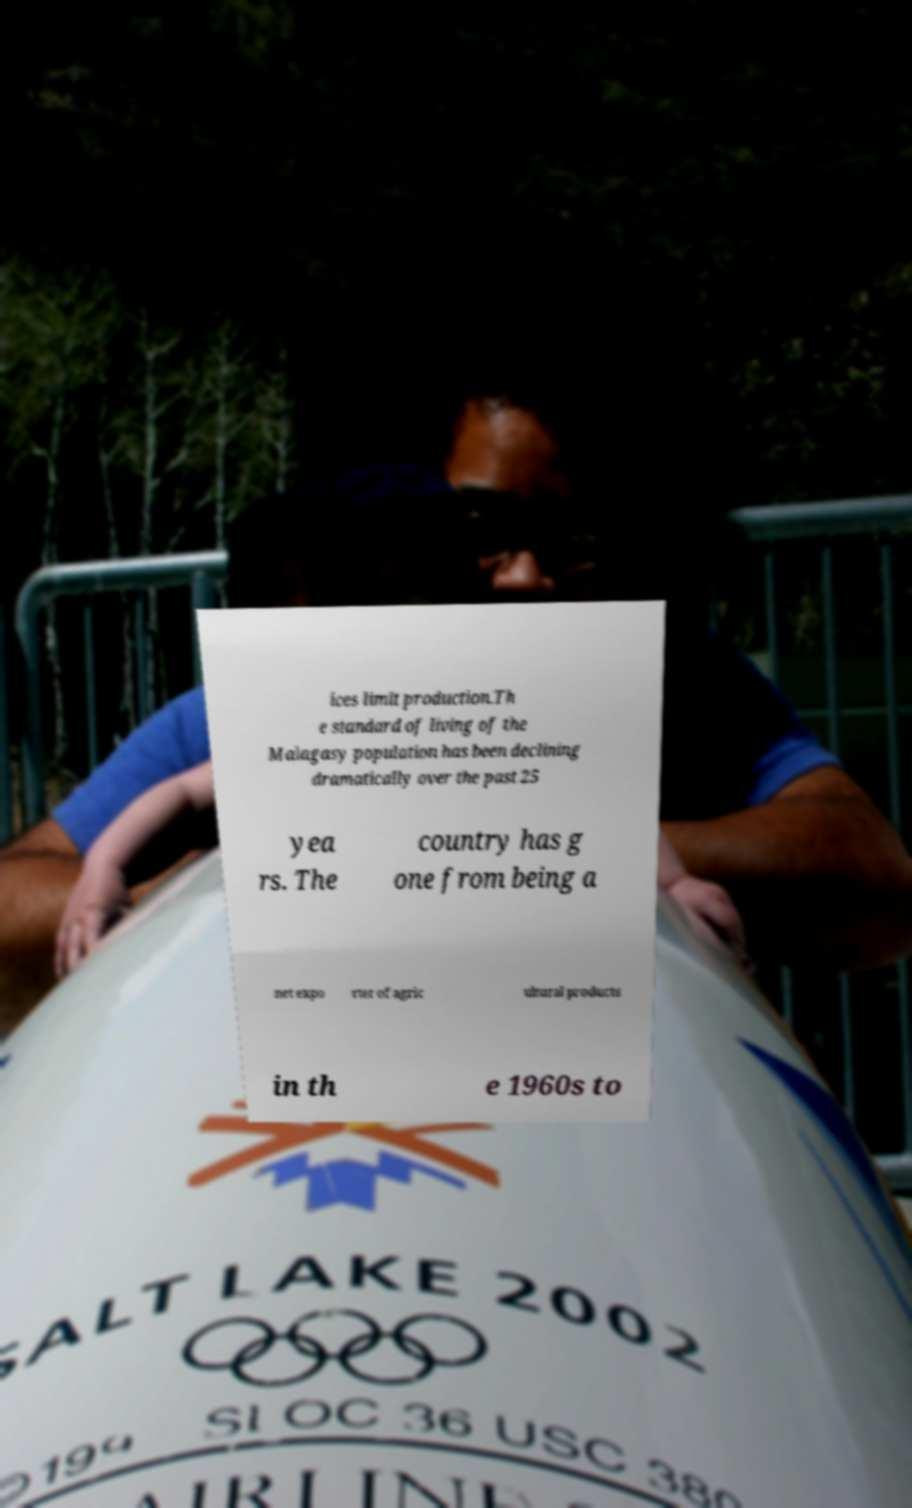Could you extract and type out the text from this image? ices limit production.Th e standard of living of the Malagasy population has been declining dramatically over the past 25 yea rs. The country has g one from being a net expo rter of agric ultural products in th e 1960s to 